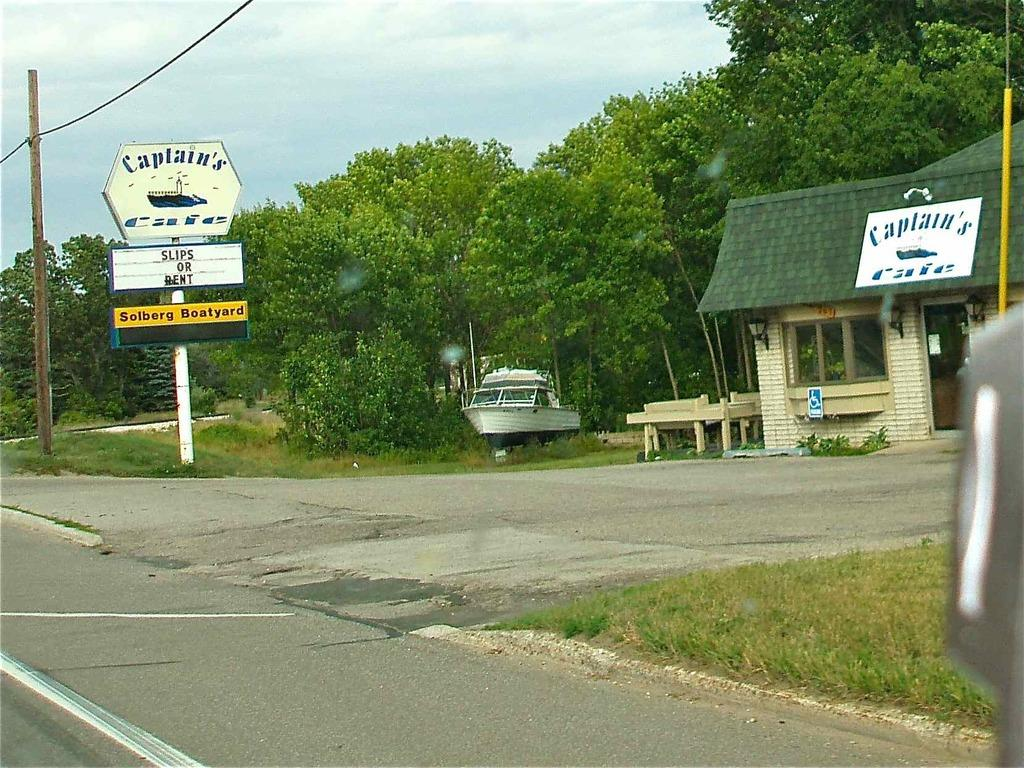What type of pathway is visible in the image? There is a road in the image. What type of vegetation is present around the road? Grass is present around the road. What other structures can be seen in the image? There is a pole, boards with names, a boat, trees, and a house on the right side of the image. What type of cake is being served by the laborer in the image? There is no laborer or cake present in the image. What emotion is the boat feeling in the image? Boats do not have emotions, so this question cannot be answered. 